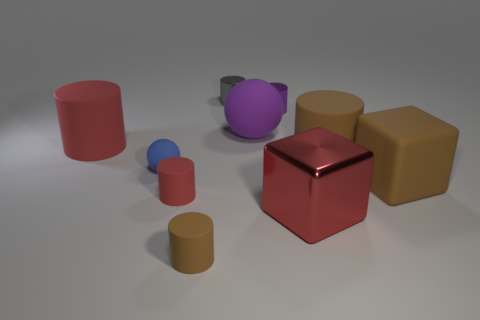Subtract all red cylinders. How many cylinders are left? 4 Subtract all brown cylinders. How many cylinders are left? 4 Subtract all gray cylinders. Subtract all red balls. How many cylinders are left? 5 Subtract all cylinders. How many objects are left? 4 Add 8 tiny gray metallic things. How many tiny gray metallic things are left? 9 Add 1 large rubber objects. How many large rubber objects exist? 5 Subtract 1 blue balls. How many objects are left? 9 Subtract all purple matte objects. Subtract all big red metallic things. How many objects are left? 8 